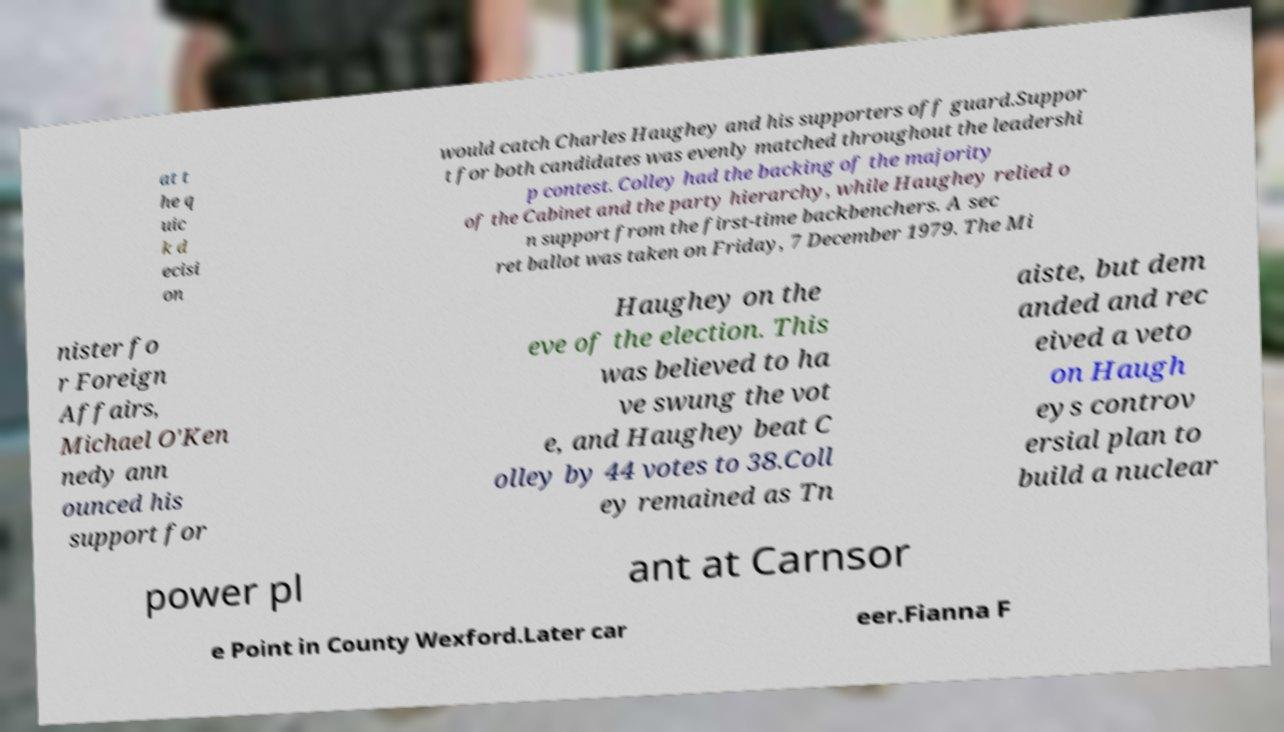Could you extract and type out the text from this image? at t he q uic k d ecisi on would catch Charles Haughey and his supporters off guard.Suppor t for both candidates was evenly matched throughout the leadershi p contest. Colley had the backing of the majority of the Cabinet and the party hierarchy, while Haughey relied o n support from the first-time backbenchers. A sec ret ballot was taken on Friday, 7 December 1979. The Mi nister fo r Foreign Affairs, Michael O'Ken nedy ann ounced his support for Haughey on the eve of the election. This was believed to ha ve swung the vot e, and Haughey beat C olley by 44 votes to 38.Coll ey remained as Tn aiste, but dem anded and rec eived a veto on Haugh eys controv ersial plan to build a nuclear power pl ant at Carnsor e Point in County Wexford.Later car eer.Fianna F 